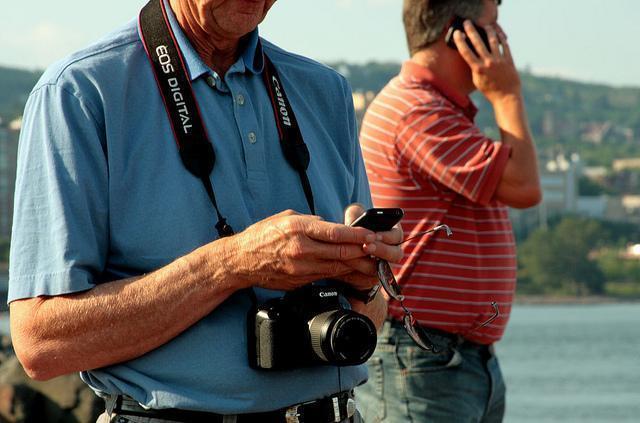What does the man do with the object around his neck?
Pick the correct solution from the four options below to address the question.
Options: Call, text, paint, take photos. Take photos. 